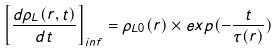Convert formula to latex. <formula><loc_0><loc_0><loc_500><loc_500>\left [ \frac { d { \rho _ { L } } ( r , t ) } { d t } \right ] _ { i n f } = \rho _ { L 0 } ( r ) \times e x p ( { - \frac { t } { \tau ( r ) } } )</formula> 